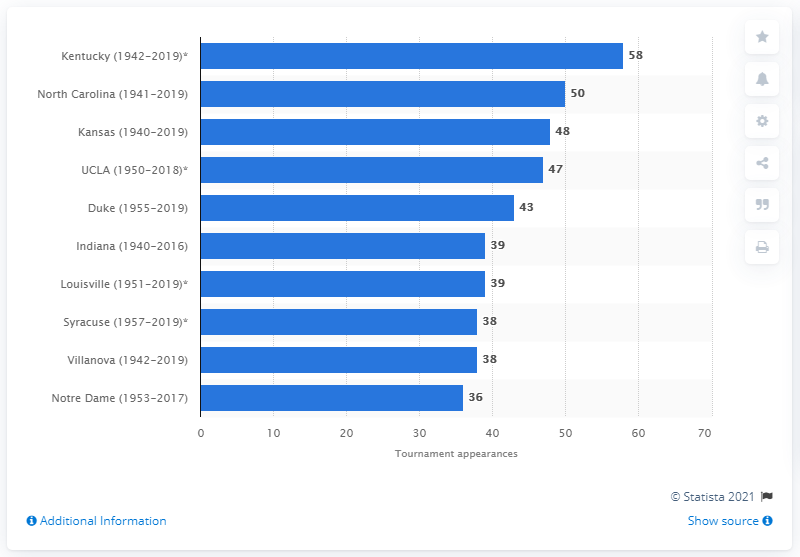Draw attention to some important aspects in this diagram. The basketball team of Kentucky has appeared in the tournament a total of 58 times between 1942 and 2020. 